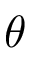<formula> <loc_0><loc_0><loc_500><loc_500>\theta</formula> 